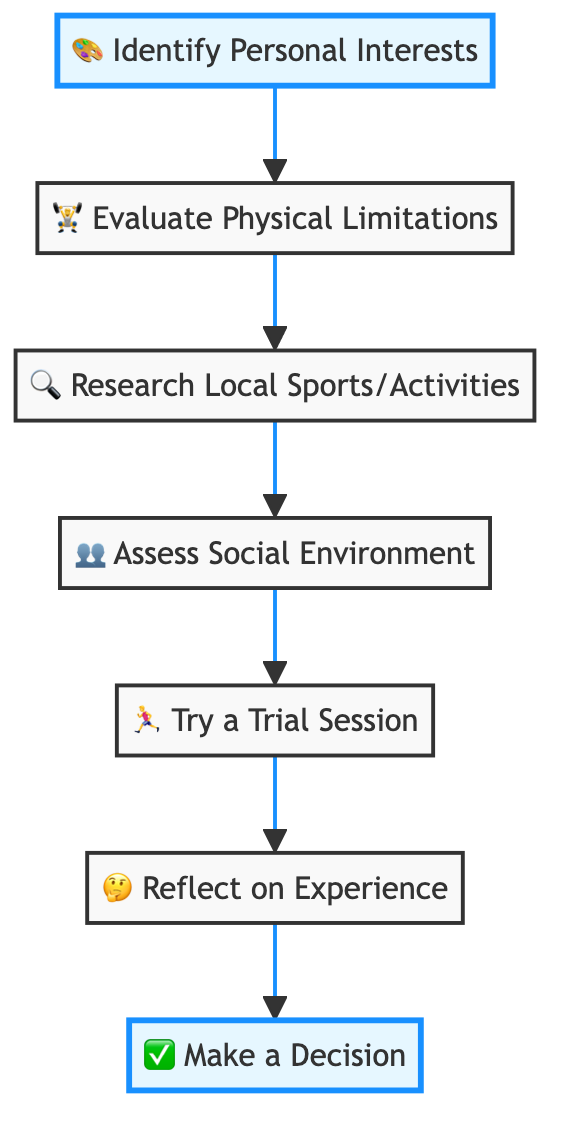What is the first step in the decision-making process? The diagram indicates that the first step is "Identify Personal Interests," which is represented as Node 1.
Answer: Identify Personal Interests How many nodes are there in the diagram? By counting the numbered nodes from 1 to 7, we find there are a total of 7 nodes in the diagram.
Answer: 7 What follows after "Evaluate Physical Limitations"? The flow indicates that after "Evaluate Physical Limitations," the next step is "Research Local Sports/Activities," which is Node 3.
Answer: Research Local Sports/Activities What is the last step in the process? The final step in the flow chart is "Make a Decision," as indicated by Node 7 at the end of the flow.
Answer: Make a Decision Which step involves trying out an activity? The diagram shows that "Try a Trial Session" is the step where individuals attend a session to experience the activity firsthand, represented as Node 5.
Answer: Try a Trial Session What is the purpose of "Reflect on Experience"? This step is intended for participants to evaluate their feelings and physical response after trying the activity, which is indicated by Node 6.
Answer: Evaluate feelings and physical response What is the relationship between "Assess Social Environment" and "Try a Trial Session"? The flow shows that "Assess Social Environment" (Node 4) directly leads to "Try a Trial Session" (Node 5), indicating that social factors are considered prior to trying the activity.
Answer: Directly leads to What is needed to start the process chain? To begin the process, you must first identify personal interests, which is the first step in the chain of actions shown in the flow chart.
Answer: Identify Personal Interests What do you assess regarding the social environment? During this step, individuals consider if friends or peers are participating and if the environment is supportive as part of evaluating their social surroundings, indicated by Node 4.
Answer: Friends or peers participation and supportive environment 